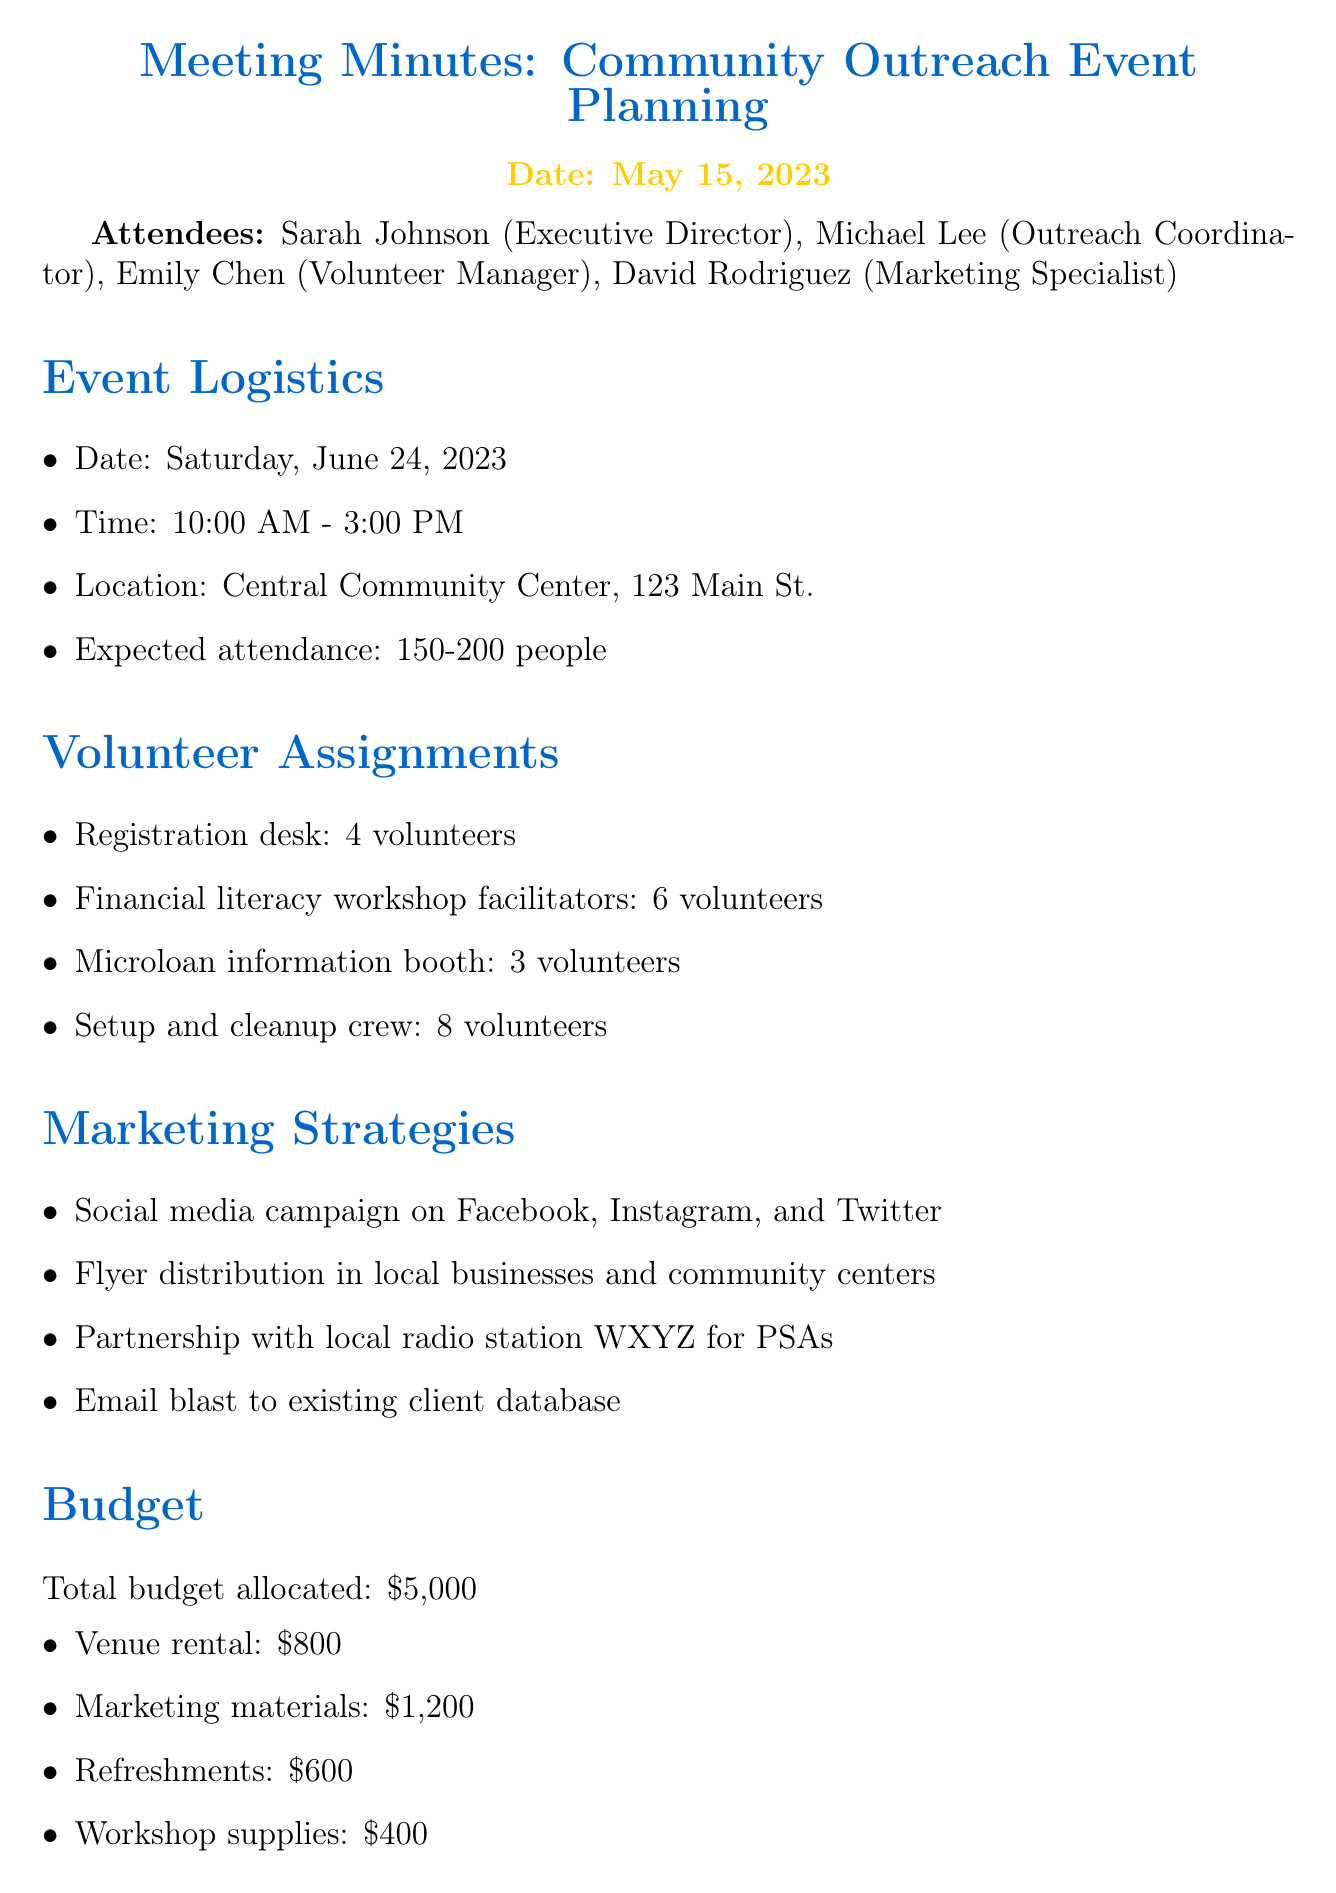what is the date of the event? The document specifies the event date as Saturday, June 24, 2023.
Answer: Saturday, June 24, 2023 how many attendees are expected at the event? The document states that the expected attendance is between 150-200 people.
Answer: 150-200 people who is responsible for finalizing the volunteer schedule? The action item indicates that Emily is tasked with finalizing the volunteer schedule by May 22.
Answer: Emily what is the total budget allocated for the event? The document lists the total budget allocated as $5,000.
Answer: $5,000 how many volunteers are needed for the registration desk? According to the volunteer assignments, 4 volunteers are required for the registration desk.
Answer: 4 volunteers what marketing strategy involves local businesses? The document mentions flyer distribution in local businesses and community centers as a marketing strategy.
Answer: Flyer distribution which action item has the earliest deadline? The earliest deadline is for David to design and order event flyers by May 19.
Answer: May 19 what is the location of the event? The meeting minutes specify that the event will be held at Central Community Center, 123 Main St.
Answer: Central Community Center, 123 Main St how many volunteers are needed for the setup and cleanup crew? The document indicates that 8 volunteers are needed for the setup and cleanup crew.
Answer: 8 volunteers 